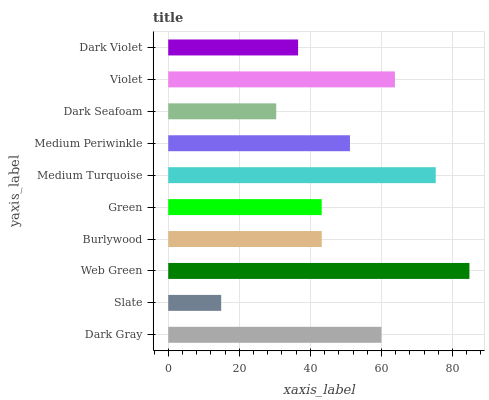Is Slate the minimum?
Answer yes or no. Yes. Is Web Green the maximum?
Answer yes or no. Yes. Is Web Green the minimum?
Answer yes or no. No. Is Slate the maximum?
Answer yes or no. No. Is Web Green greater than Slate?
Answer yes or no. Yes. Is Slate less than Web Green?
Answer yes or no. Yes. Is Slate greater than Web Green?
Answer yes or no. No. Is Web Green less than Slate?
Answer yes or no. No. Is Medium Periwinkle the high median?
Answer yes or no. Yes. Is Burlywood the low median?
Answer yes or no. Yes. Is Dark Gray the high median?
Answer yes or no. No. Is Web Green the low median?
Answer yes or no. No. 